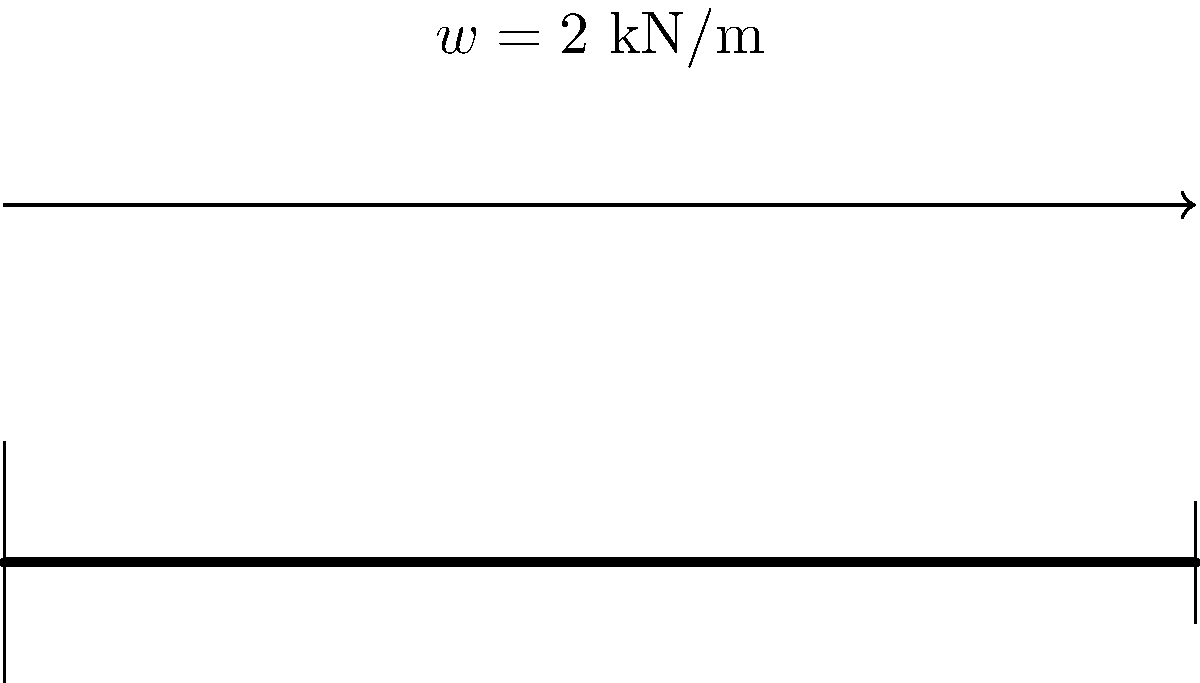A simply supported beam AB of length 5 m is subjected to a uniformly distributed load of 2 kN/m along its entire length. Determine the maximum bending moment in the beam. To find the maximum bending moment, we'll follow these steps:

1) First, calculate the total load on the beam:
   $W = w \times L = 2 \text{ kN/m} \times 5 \text{ m} = 10 \text{ kN}$

2) For a simply supported beam with a uniformly distributed load, the reactions at the supports are equal and each is half of the total load:
   $R_A = R_B = \frac{W}{2} = \frac{10 \text{ kN}}{2} = 5 \text{ kN}$

3) The maximum bending moment in a simply supported beam with a uniformly distributed load occurs at the center of the beam and is given by the formula:
   $M_{max} = \frac{wL^2}{8}$

4) Substituting the values:
   $M_{max} = \frac{2 \text{ kN/m} \times (5 \text{ m})^2}{8} = \frac{50}{8} = 6.25 \text{ kN}\cdot\text{m}$

Therefore, the maximum bending moment in the beam is 6.25 kN·m.
Answer: 6.25 kN·m 